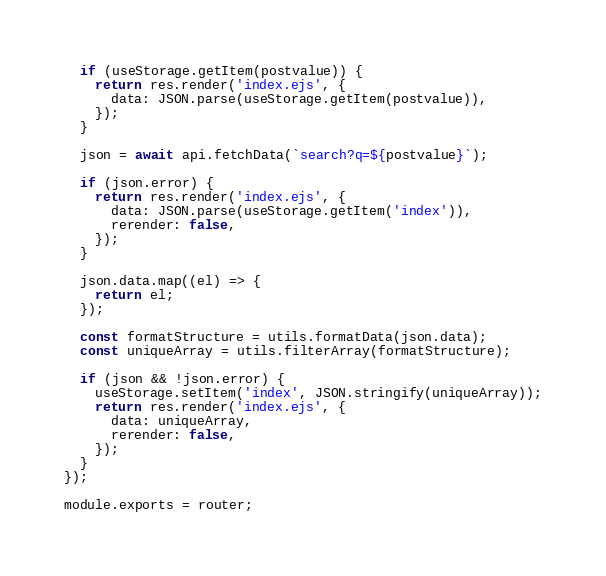Convert code to text. <code><loc_0><loc_0><loc_500><loc_500><_JavaScript_>  if (useStorage.getItem(postvalue)) {
    return res.render('index.ejs', {
      data: JSON.parse(useStorage.getItem(postvalue)),
    });
  }

  json = await api.fetchData(`search?q=${postvalue}`);

  if (json.error) {
    return res.render('index.ejs', {
      data: JSON.parse(useStorage.getItem('index')),
      rerender: false,
    });
  }

  json.data.map((el) => {
    return el;
  });

  const formatStructure = utils.formatData(json.data);
  const uniqueArray = utils.filterArray(formatStructure);

  if (json && !json.error) {
    useStorage.setItem('index', JSON.stringify(uniqueArray));
    return res.render('index.ejs', {
      data: uniqueArray,
      rerender: false,
    });
  }
});

module.exports = router;
</code> 